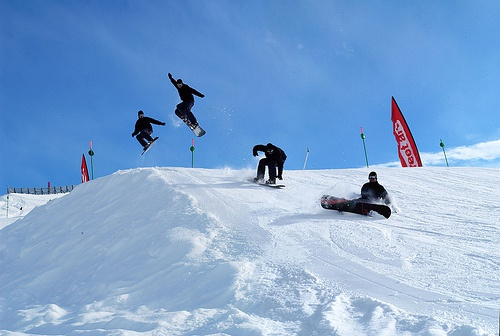Describe the objects in this image and their specific colors. I can see snowboard in blue, black, gray, and darkgray tones, people in blue, black, gray, lightblue, and darkgray tones, people in blue, black, navy, lightblue, and gray tones, people in blue, black, gray, navy, and darkgray tones, and people in blue, black, lightblue, and navy tones in this image. 